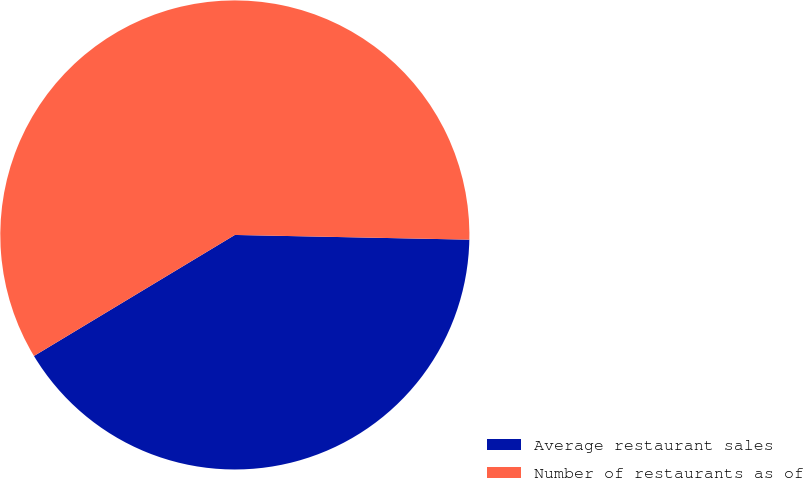Convert chart to OTSL. <chart><loc_0><loc_0><loc_500><loc_500><pie_chart><fcel>Average restaurant sales<fcel>Number of restaurants as of<nl><fcel>41.05%<fcel>58.95%<nl></chart> 